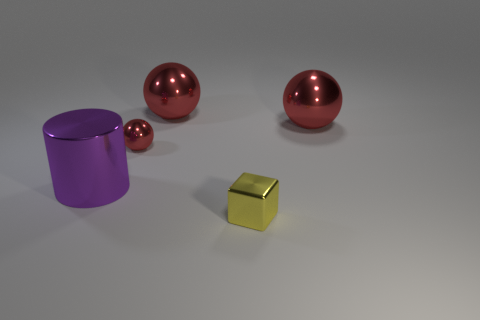Can you tell me the sizes of the objects relative to each other? Certainly, the yellow cube is the smallest object, followed by the smaller red sphere. The violet cylinder is of medium size, and the larger red sphere is the biggest object in the image. This range of sizes adds to the dynamics of the scene. 